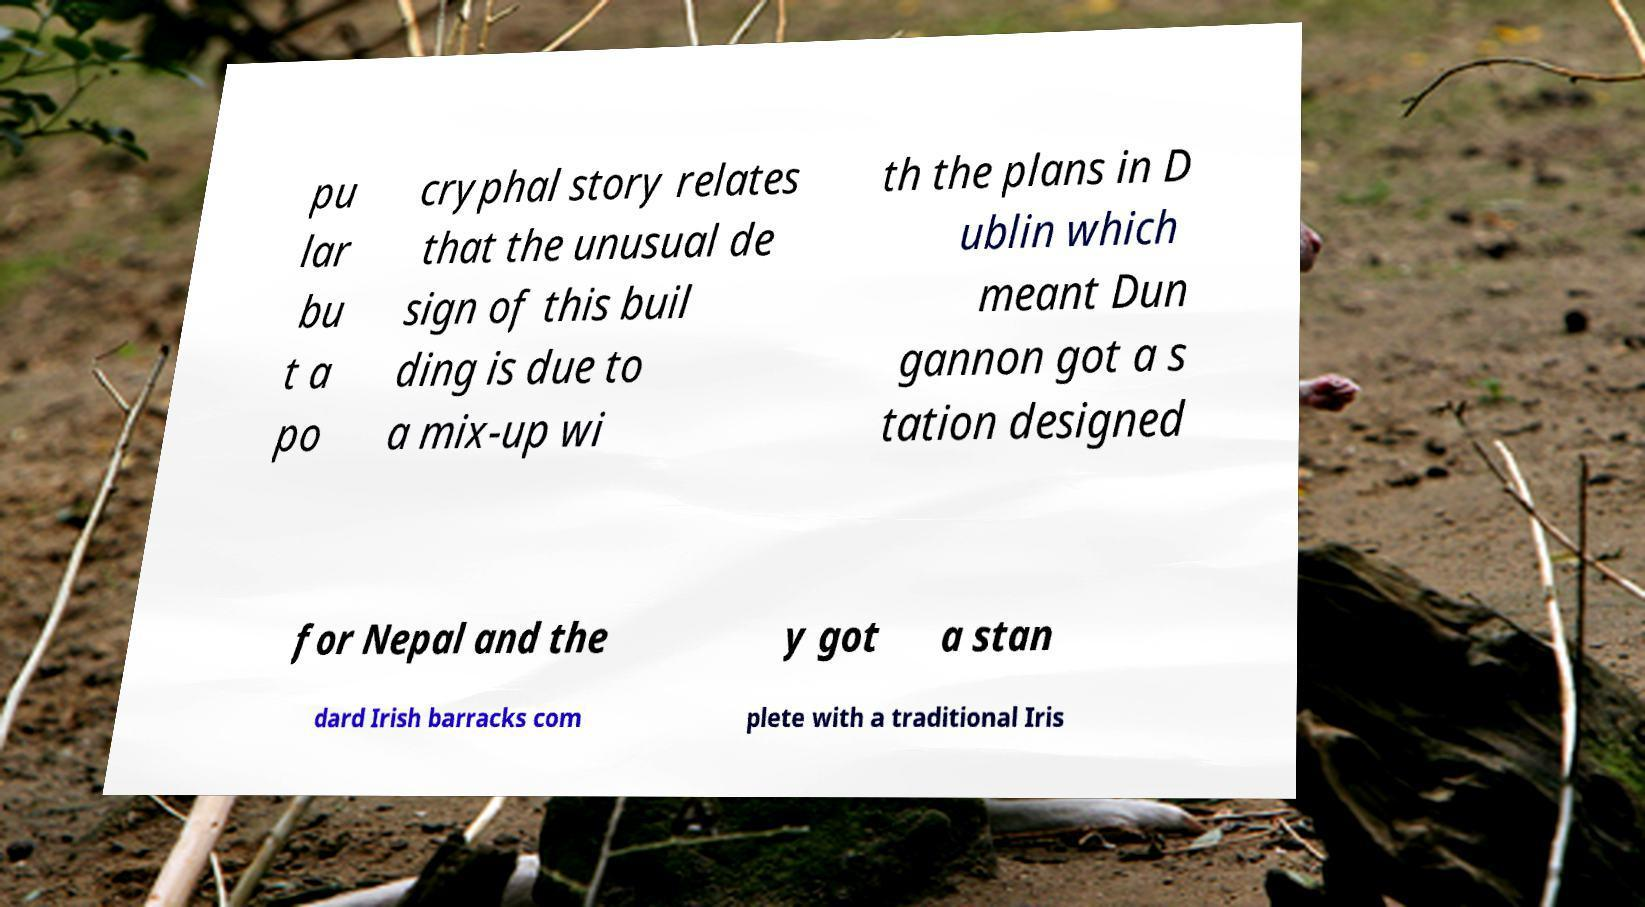For documentation purposes, I need the text within this image transcribed. Could you provide that? pu lar bu t a po cryphal story relates that the unusual de sign of this buil ding is due to a mix-up wi th the plans in D ublin which meant Dun gannon got a s tation designed for Nepal and the y got a stan dard Irish barracks com plete with a traditional Iris 